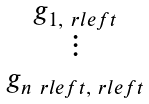<formula> <loc_0><loc_0><loc_500><loc_500>\begin{matrix} g _ { 1 , \ r l e f t } \\ \vdots \\ g _ { n _ { \ } r l e f t , \ r l e f t } \end{matrix}</formula> 